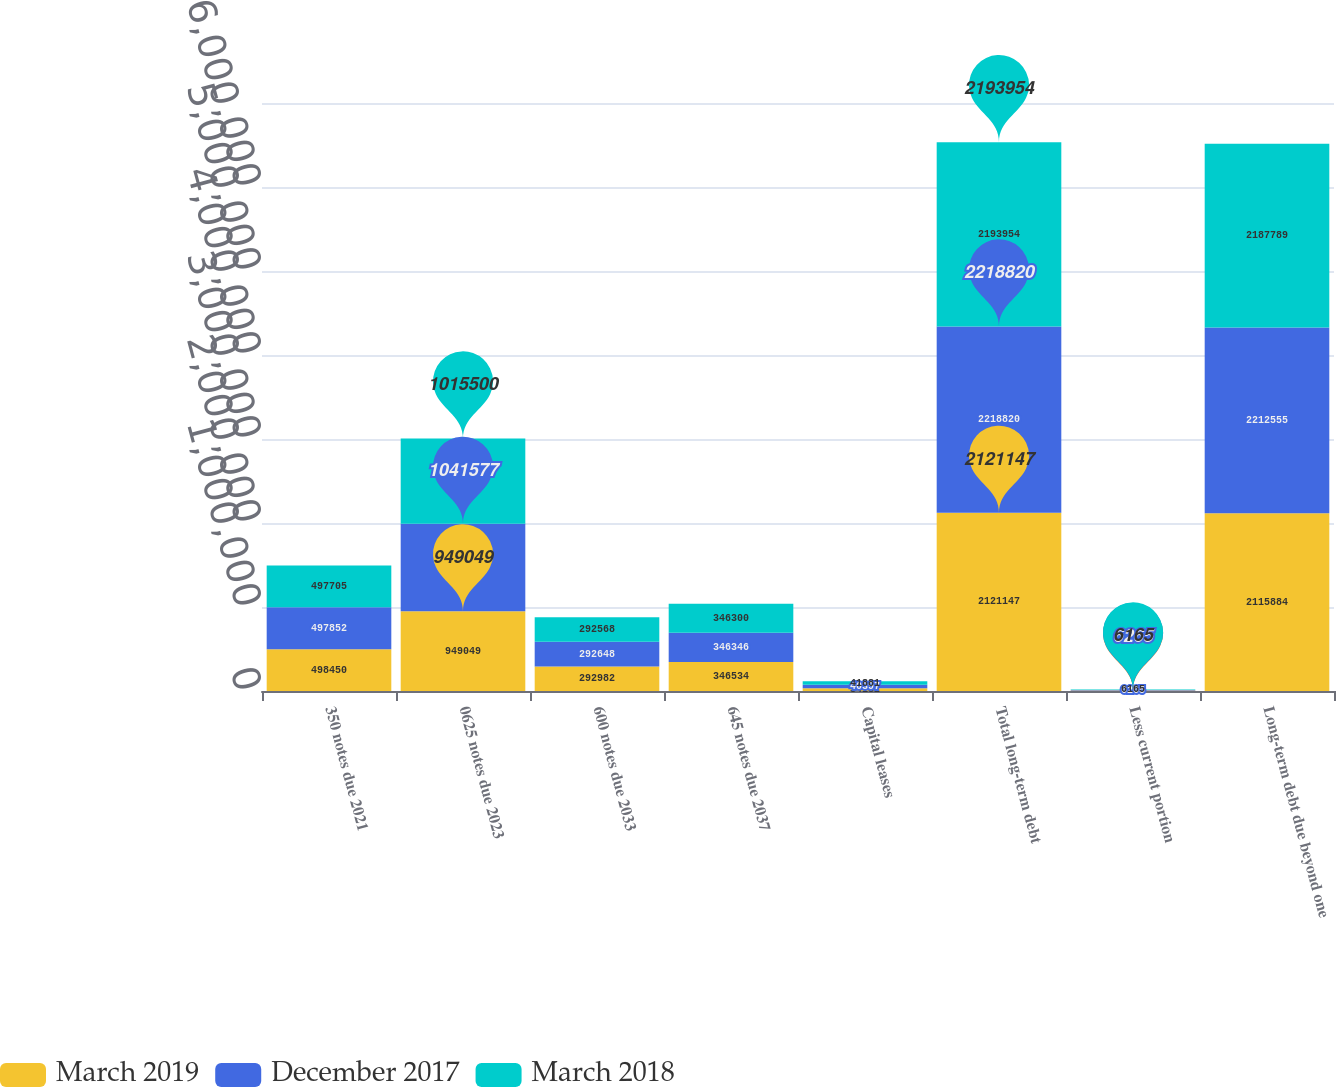<chart> <loc_0><loc_0><loc_500><loc_500><stacked_bar_chart><ecel><fcel>350 notes due 2021<fcel>0625 notes due 2023<fcel>600 notes due 2033<fcel>645 notes due 2037<fcel>Capital leases<fcel>Total long-term debt<fcel>Less current portion<fcel>Long-term debt due beyond one<nl><fcel>March 2019<fcel>498450<fcel>949049<fcel>292982<fcel>346534<fcel>34132<fcel>2.12115e+06<fcel>5263<fcel>2.11588e+06<nl><fcel>December 2017<fcel>497852<fcel>1.04158e+06<fcel>292648<fcel>346346<fcel>40397<fcel>2.21882e+06<fcel>6265<fcel>2.21256e+06<nl><fcel>March 2018<fcel>497705<fcel>1.0155e+06<fcel>292568<fcel>346300<fcel>41881<fcel>2.19395e+06<fcel>6165<fcel>2.18779e+06<nl></chart> 